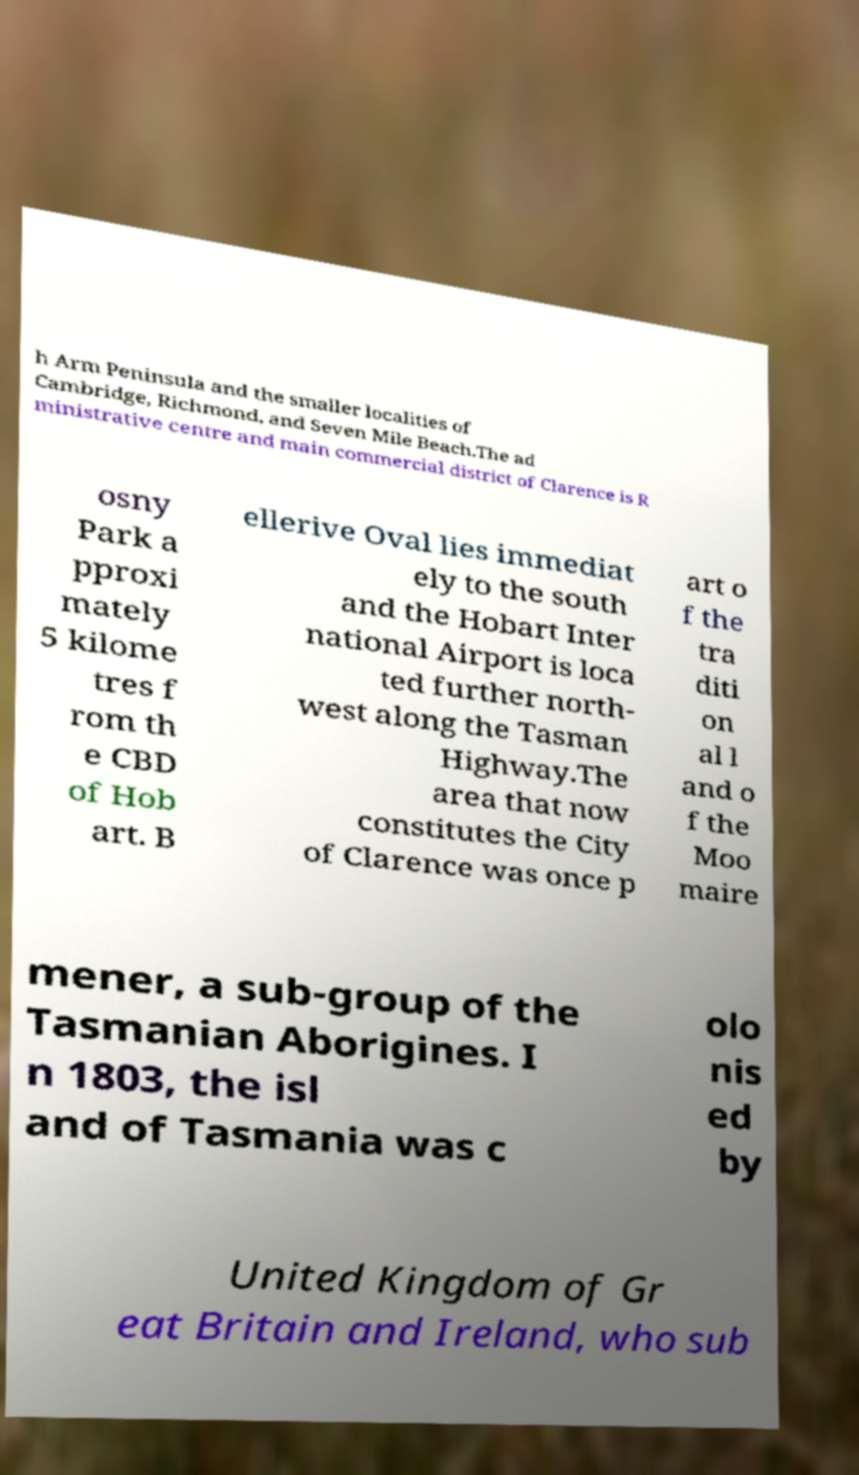For documentation purposes, I need the text within this image transcribed. Could you provide that? h Arm Peninsula and the smaller localities of Cambridge, Richmond, and Seven Mile Beach.The ad ministrative centre and main commercial district of Clarence is R osny Park a pproxi mately 5 kilome tres f rom th e CBD of Hob art. B ellerive Oval lies immediat ely to the south and the Hobart Inter national Airport is loca ted further north- west along the Tasman Highway.The area that now constitutes the City of Clarence was once p art o f the tra diti on al l and o f the Moo maire mener, a sub-group of the Tasmanian Aborigines. I n 1803, the isl and of Tasmania was c olo nis ed by United Kingdom of Gr eat Britain and Ireland, who sub 